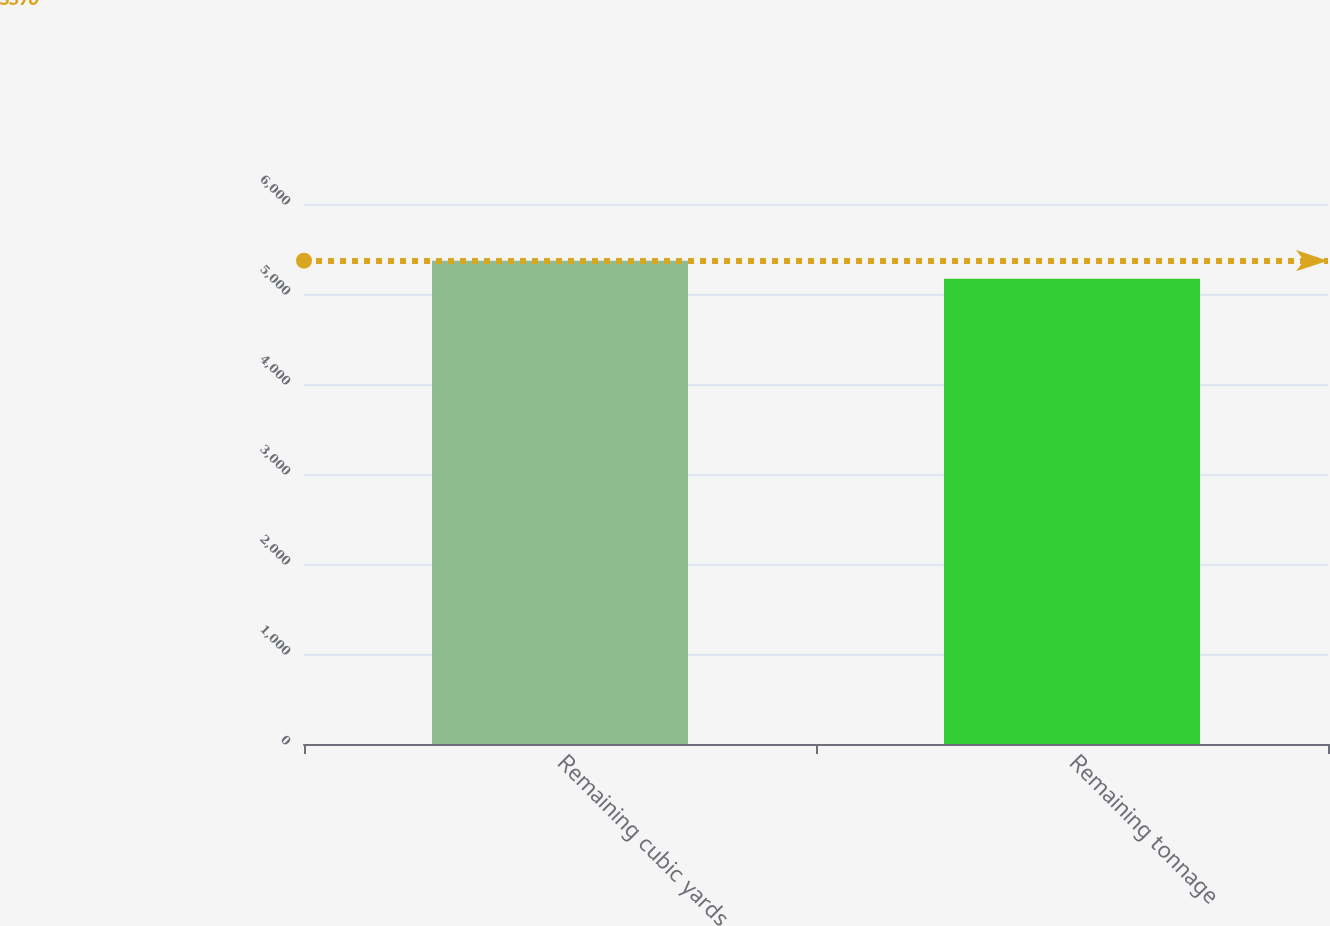Convert chart to OTSL. <chart><loc_0><loc_0><loc_500><loc_500><bar_chart><fcel>Remaining cubic yards<fcel>Remaining tonnage<nl><fcel>5370<fcel>5170<nl></chart> 